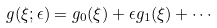<formula> <loc_0><loc_0><loc_500><loc_500>g ( \xi ; \epsilon ) = g _ { 0 } ( \xi ) + \epsilon g _ { 1 } ( \xi ) + \cdots</formula> 